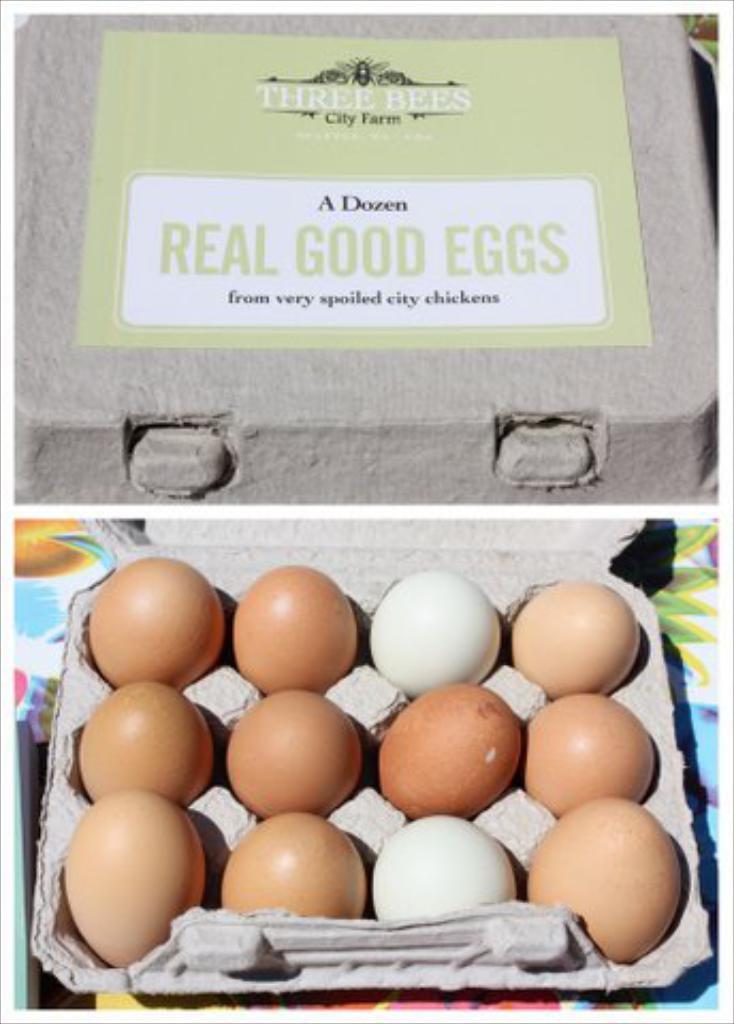Describe this image in one or two sentences. In the image there are eggs kept in an egg tray, behind that there is some object and a sticker with some names. 